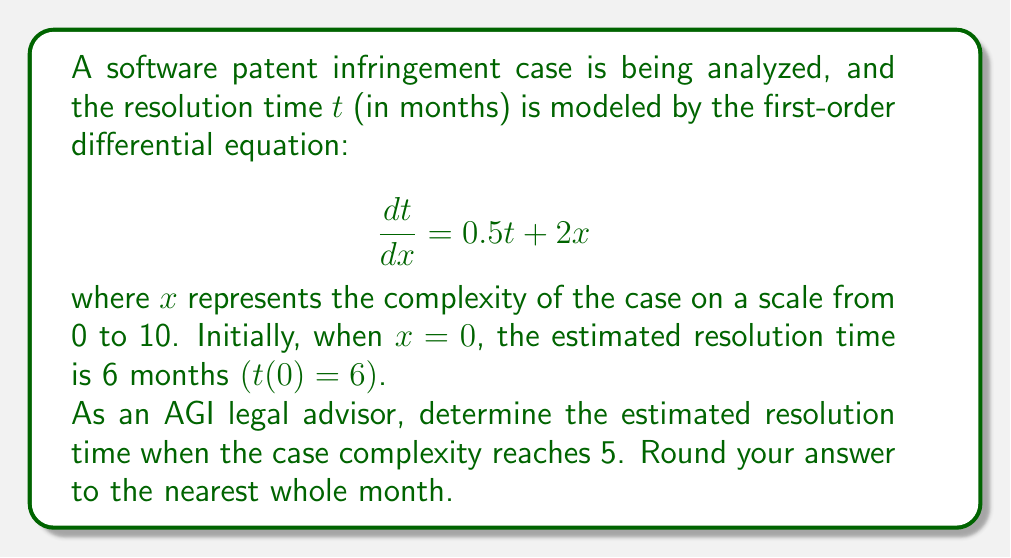Can you solve this math problem? Let's solve this step-by-step:

1) We have a first-order linear differential equation:
   $$\frac{dt}{dx} = 0.5t + 2x$$

2) This is in the form $\frac{dt}{dx} + P(x)t = Q(x)$, where $P(x) = -0.5$ and $Q(x) = 2x$.

3) The integrating factor is $\mu(x) = e^{\int P(x)dx} = e^{-0.5x}$.

4) Multiplying both sides by $\mu(x)$:
   $$e^{-0.5x}\frac{dt}{dx} + 0.5e^{-0.5x}t = 2xe^{-0.5x}$$

5) The left side is now the derivative of $e^{-0.5x}t$. So we can write:
   $$\frac{d}{dx}(e^{-0.5x}t) = 2xe^{-0.5x}$$

6) Integrating both sides:
   $$e^{-0.5x}t = \int 2xe^{-0.5x}dx = -4xe^{-0.5x} - 8e^{-0.5x} + C$$

7) Solving for $t$:
   $$t = -4x - 8 + Ce^{0.5x}$$

8) Using the initial condition $t(0) = 6$:
   $$6 = -4(0) - 8 + C$$
   $$C = 14$$

9) Therefore, the general solution is:
   $$t = -4x - 8 + 14e^{0.5x}$$

10) To find $t$ when $x = 5$:
    $$t(5) = -4(5) - 8 + 14e^{0.5(5)}$$
    $$= -20 - 8 + 14e^{2.5}$$
    $$\approx 129.7$$

11) Rounding to the nearest whole month:
    $$t(5) \approx 130$$
Answer: 130 months 